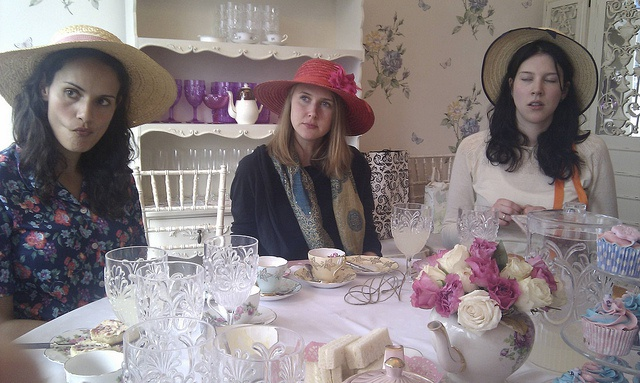Describe the objects in this image and their specific colors. I can see dining table in white, darkgray, lightgray, and gray tones, people in white, black, gray, and darkgray tones, people in white, darkgray, gray, and black tones, people in white, black, gray, maroon, and brown tones, and chair in white, lightgray, darkgray, and gray tones in this image. 